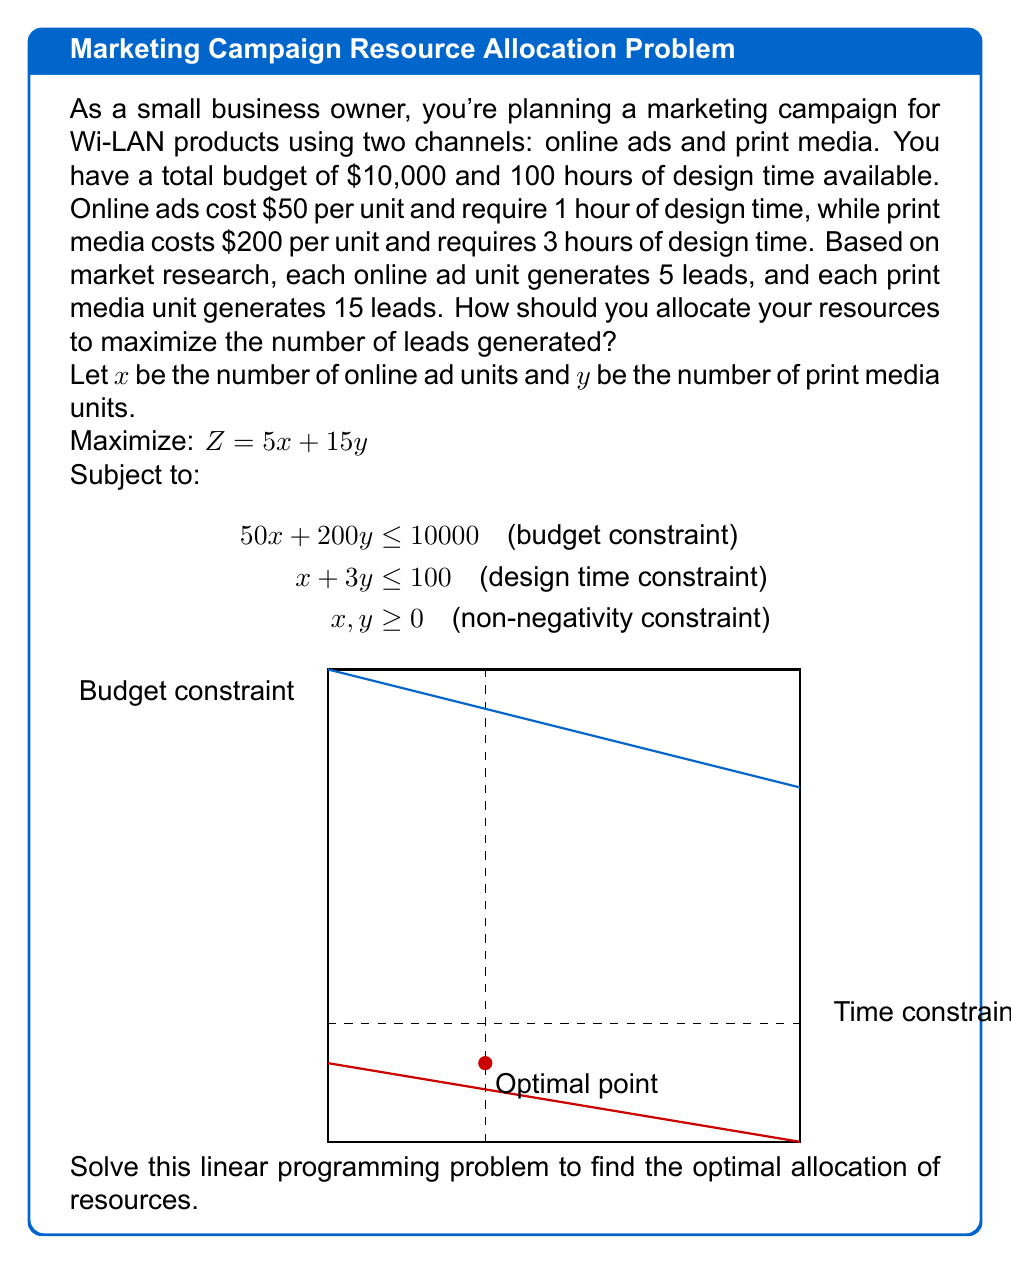Could you help me with this problem? To solve this linear programming problem, we'll use the graphical method:

1) First, plot the constraints:
   - Budget constraint: $50x + 200y = 10000$ or $y = 50 - 0.25x$
   - Time constraint: $x + 3y = 100$ or $y = 33.33 - 0.33x$

2) The feasible region is the area bounded by these lines and the non-negative axes.

3) The optimal solution will be at one of the corner points of this region. The corner points are:
   (0, 0), (200, 0), (66.67, 33.33), and (0, 33.33)

4) Calculate the objective function value (Z) at each point:
   - (0, 0): Z = 0
   - (200, 0): Z = 1000
   - (66.67, 33.33): Z = 833.35
   - (0, 33.33): Z = 499.95

5) The maximum value of Z occurs at the point (66.67, 33.33).

6) However, we need integer solutions. Rounding down to ensure we don't exceed constraints:
   x = 66 (online ad units)
   y = 33 (print media units)

7) Verify constraints:
   Budget: 50(66) + 200(33) = 9900 ≤ 10000
   Time: 66 + 3(33) = 165 ≤ 100

8) Calculate total leads:
   5(66) + 15(33) = 330 + 495 = 825 leads

Therefore, the optimal allocation is 66 online ad units and 33 print media units, generating 825 leads.
Answer: 66 online ad units, 33 print media units; 825 leads 